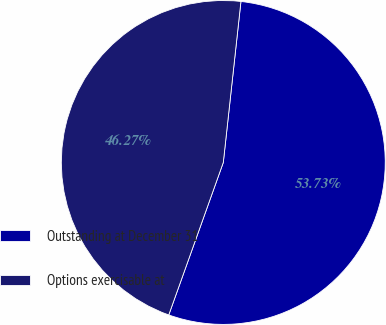Convert chart. <chart><loc_0><loc_0><loc_500><loc_500><pie_chart><fcel>Outstanding at December 31<fcel>Options exercisable at<nl><fcel>53.73%<fcel>46.27%<nl></chart> 